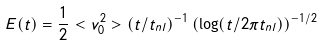<formula> <loc_0><loc_0><loc_500><loc_500>E ( t ) = \frac { 1 } { 2 } < v _ { 0 } ^ { 2 } > ( t / t _ { n l } ) ^ { - 1 } \left ( \log ( t / 2 \pi t _ { n l } ) \right ) ^ { - 1 / 2 }</formula> 